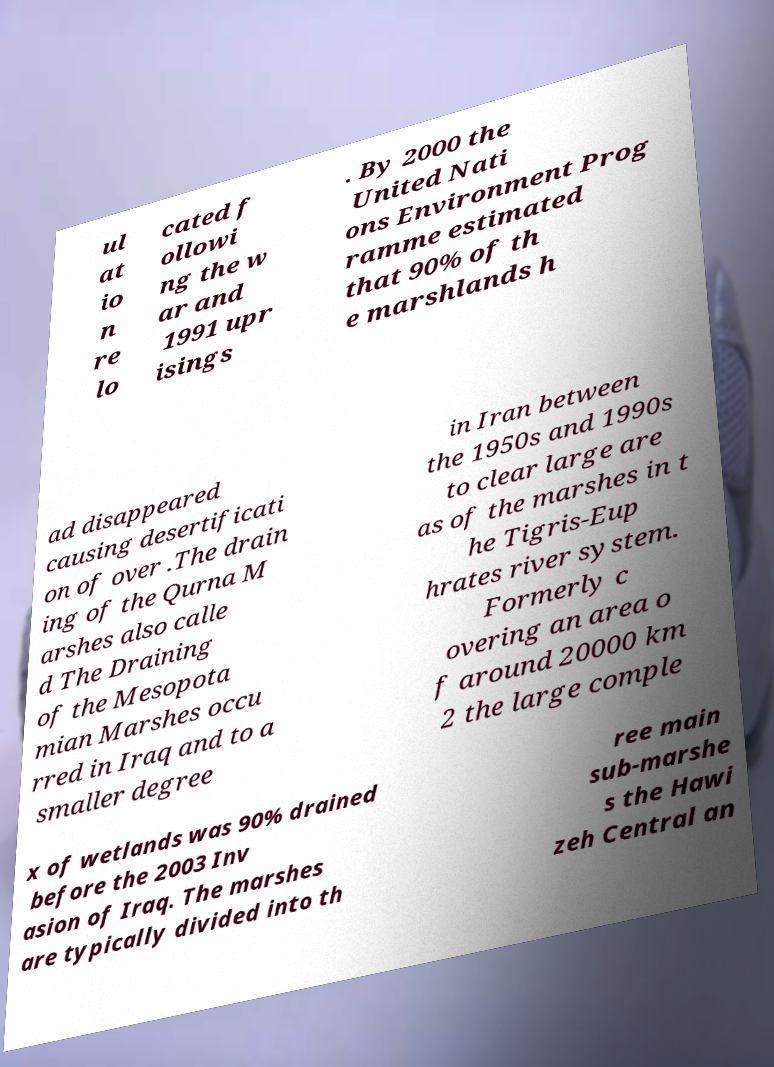Can you accurately transcribe the text from the provided image for me? ul at io n re lo cated f ollowi ng the w ar and 1991 upr isings . By 2000 the United Nati ons Environment Prog ramme estimated that 90% of th e marshlands h ad disappeared causing desertificati on of over .The drain ing of the Qurna M arshes also calle d The Draining of the Mesopota mian Marshes occu rred in Iraq and to a smaller degree in Iran between the 1950s and 1990s to clear large are as of the marshes in t he Tigris-Eup hrates river system. Formerly c overing an area o f around 20000 km 2 the large comple x of wetlands was 90% drained before the 2003 Inv asion of Iraq. The marshes are typically divided into th ree main sub-marshe s the Hawi zeh Central an 